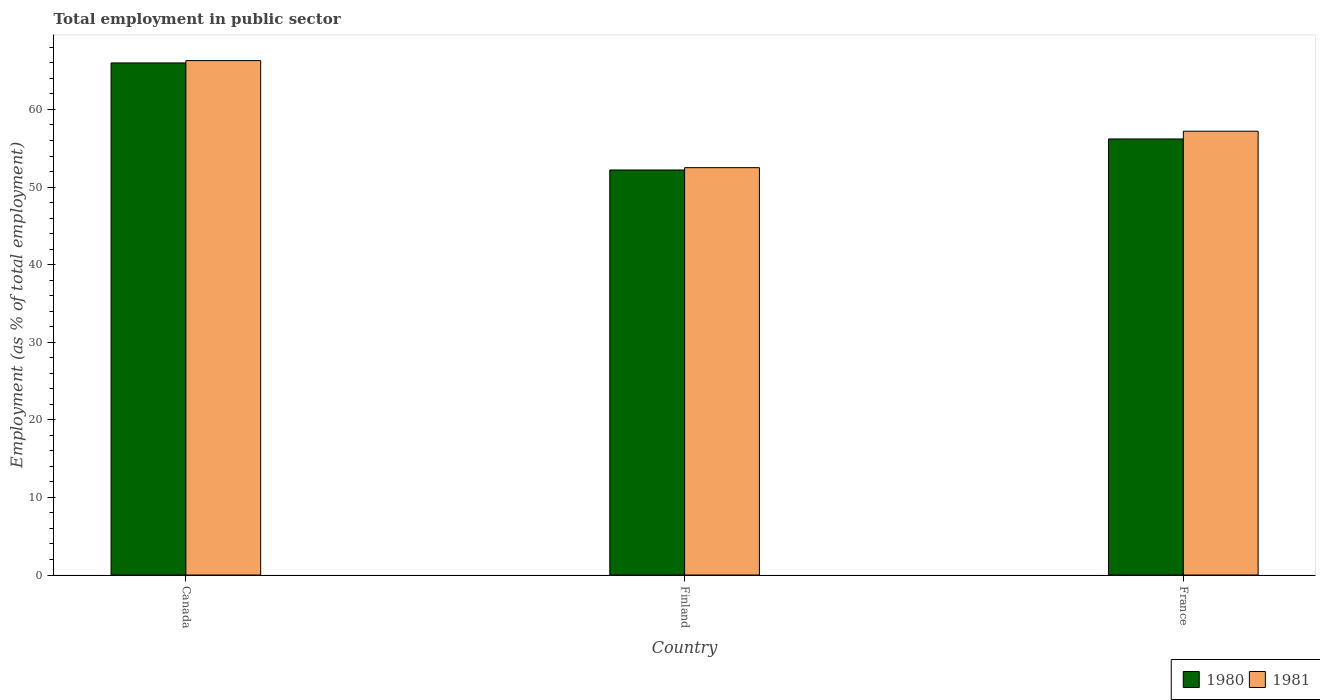How many groups of bars are there?
Offer a terse response. 3. Are the number of bars per tick equal to the number of legend labels?
Your answer should be very brief. Yes. Are the number of bars on each tick of the X-axis equal?
Your response must be concise. Yes. What is the label of the 3rd group of bars from the left?
Provide a short and direct response. France. What is the employment in public sector in 1981 in Canada?
Your answer should be very brief. 66.3. Across all countries, what is the maximum employment in public sector in 1980?
Offer a very short reply. 66. Across all countries, what is the minimum employment in public sector in 1980?
Your answer should be very brief. 52.2. In which country was the employment in public sector in 1981 maximum?
Make the answer very short. Canada. In which country was the employment in public sector in 1980 minimum?
Your response must be concise. Finland. What is the total employment in public sector in 1981 in the graph?
Your answer should be very brief. 176. What is the difference between the employment in public sector in 1981 in Canada and that in France?
Provide a short and direct response. 9.1. What is the average employment in public sector in 1981 per country?
Your answer should be compact. 58.67. In how many countries, is the employment in public sector in 1981 greater than 6 %?
Ensure brevity in your answer.  3. What is the ratio of the employment in public sector in 1981 in Canada to that in France?
Your answer should be compact. 1.16. Is the difference between the employment in public sector in 1980 in Canada and Finland greater than the difference between the employment in public sector in 1981 in Canada and Finland?
Offer a terse response. No. What is the difference between the highest and the second highest employment in public sector in 1980?
Provide a succinct answer. -9.8. What is the difference between the highest and the lowest employment in public sector in 1980?
Provide a succinct answer. 13.8. In how many countries, is the employment in public sector in 1980 greater than the average employment in public sector in 1980 taken over all countries?
Ensure brevity in your answer.  1. Is the sum of the employment in public sector in 1981 in Canada and France greater than the maximum employment in public sector in 1980 across all countries?
Give a very brief answer. Yes. What is the difference between two consecutive major ticks on the Y-axis?
Your answer should be compact. 10. Are the values on the major ticks of Y-axis written in scientific E-notation?
Your response must be concise. No. Does the graph contain grids?
Your answer should be very brief. No. What is the title of the graph?
Your answer should be compact. Total employment in public sector. What is the label or title of the X-axis?
Provide a succinct answer. Country. What is the label or title of the Y-axis?
Provide a short and direct response. Employment (as % of total employment). What is the Employment (as % of total employment) of 1981 in Canada?
Give a very brief answer. 66.3. What is the Employment (as % of total employment) of 1980 in Finland?
Your response must be concise. 52.2. What is the Employment (as % of total employment) in 1981 in Finland?
Your response must be concise. 52.5. What is the Employment (as % of total employment) in 1980 in France?
Provide a succinct answer. 56.2. What is the Employment (as % of total employment) of 1981 in France?
Offer a terse response. 57.2. Across all countries, what is the maximum Employment (as % of total employment) in 1980?
Make the answer very short. 66. Across all countries, what is the maximum Employment (as % of total employment) in 1981?
Provide a succinct answer. 66.3. Across all countries, what is the minimum Employment (as % of total employment) in 1980?
Offer a very short reply. 52.2. Across all countries, what is the minimum Employment (as % of total employment) in 1981?
Give a very brief answer. 52.5. What is the total Employment (as % of total employment) of 1980 in the graph?
Give a very brief answer. 174.4. What is the total Employment (as % of total employment) in 1981 in the graph?
Offer a terse response. 176. What is the difference between the Employment (as % of total employment) in 1980 in Canada and that in Finland?
Your answer should be compact. 13.8. What is the difference between the Employment (as % of total employment) of 1981 in Canada and that in Finland?
Keep it short and to the point. 13.8. What is the difference between the Employment (as % of total employment) in 1980 in Finland and that in France?
Make the answer very short. -4. What is the difference between the Employment (as % of total employment) of 1981 in Finland and that in France?
Provide a short and direct response. -4.7. What is the difference between the Employment (as % of total employment) in 1980 in Canada and the Employment (as % of total employment) in 1981 in Finland?
Your answer should be compact. 13.5. What is the average Employment (as % of total employment) of 1980 per country?
Offer a very short reply. 58.13. What is the average Employment (as % of total employment) of 1981 per country?
Make the answer very short. 58.67. What is the ratio of the Employment (as % of total employment) in 1980 in Canada to that in Finland?
Your answer should be compact. 1.26. What is the ratio of the Employment (as % of total employment) in 1981 in Canada to that in Finland?
Give a very brief answer. 1.26. What is the ratio of the Employment (as % of total employment) in 1980 in Canada to that in France?
Your answer should be compact. 1.17. What is the ratio of the Employment (as % of total employment) of 1981 in Canada to that in France?
Offer a terse response. 1.16. What is the ratio of the Employment (as % of total employment) in 1980 in Finland to that in France?
Provide a short and direct response. 0.93. What is the ratio of the Employment (as % of total employment) of 1981 in Finland to that in France?
Offer a very short reply. 0.92. What is the difference between the highest and the second highest Employment (as % of total employment) in 1980?
Give a very brief answer. 9.8. What is the difference between the highest and the lowest Employment (as % of total employment) of 1980?
Provide a short and direct response. 13.8. 